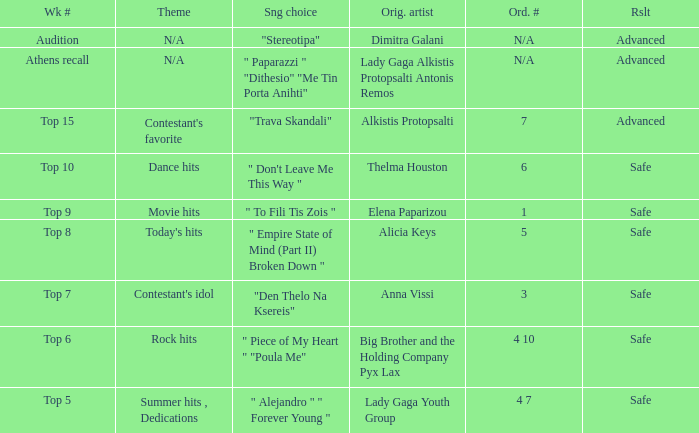Which week had the song choice " empire state of mind (part ii) broken down "? Top 8. 